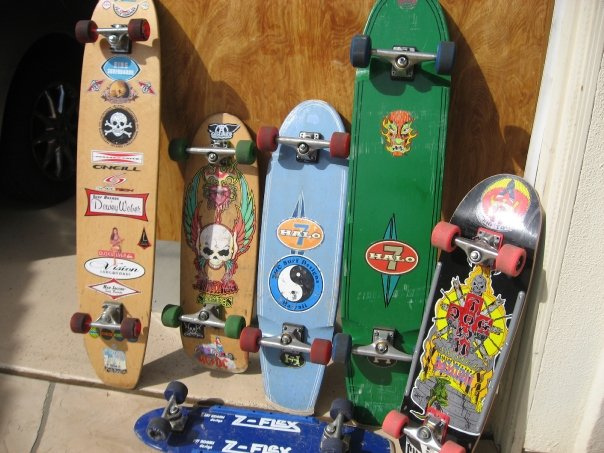Please identify all text content in this image. HALO c Z-FLEX 7 7 